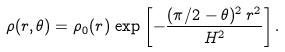<formula> <loc_0><loc_0><loc_500><loc_500>\rho ( r , \theta ) = \rho _ { 0 } ( r ) \, \exp \left [ - \frac { ( \pi / 2 - \theta ) ^ { 2 } \, r ^ { 2 } } { H ^ { 2 } } \right ] .</formula> 